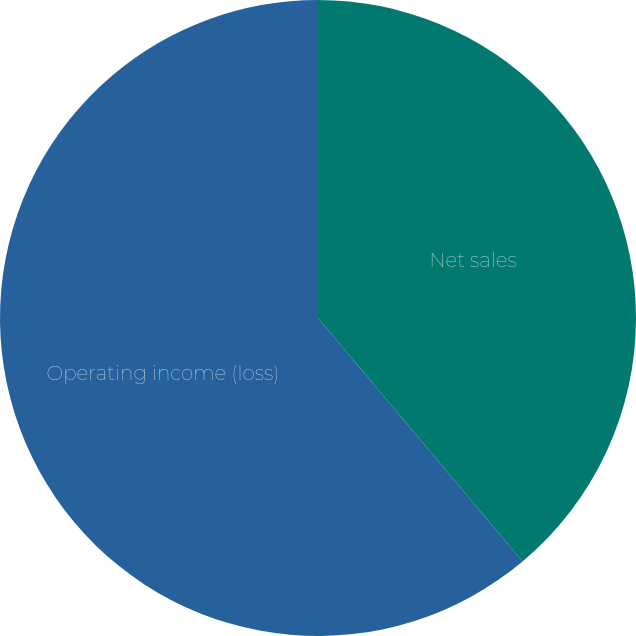<chart> <loc_0><loc_0><loc_500><loc_500><pie_chart><fcel>Net sales<fcel>Operating income (loss)<nl><fcel>38.88%<fcel>61.12%<nl></chart> 